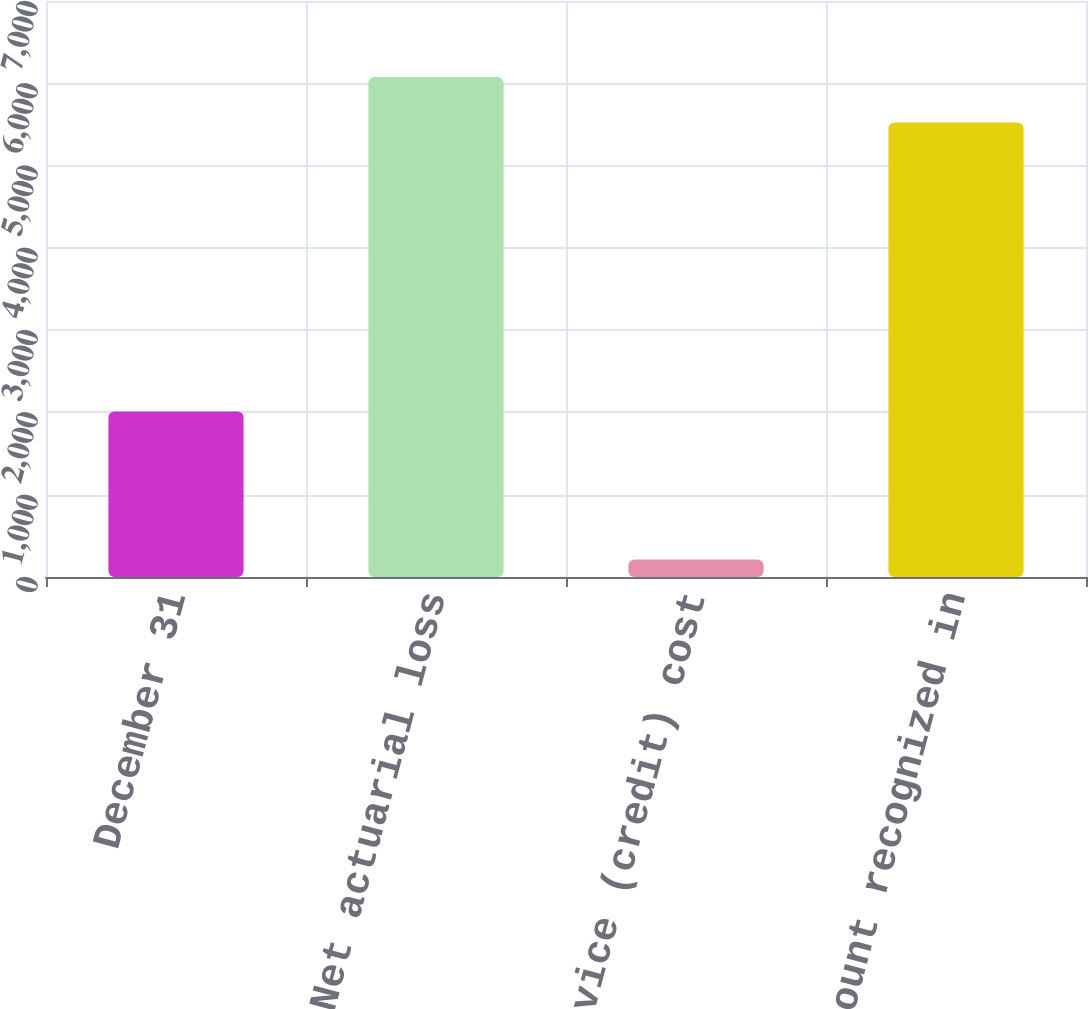<chart> <loc_0><loc_0><loc_500><loc_500><bar_chart><fcel>December 31<fcel>Net actuarial loss<fcel>Prior service (credit) cost<fcel>Total amount recognized in<nl><fcel>2012<fcel>6075.3<fcel>214<fcel>5523<nl></chart> 